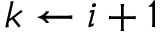<formula> <loc_0><loc_0><loc_500><loc_500>k \gets i + 1</formula> 